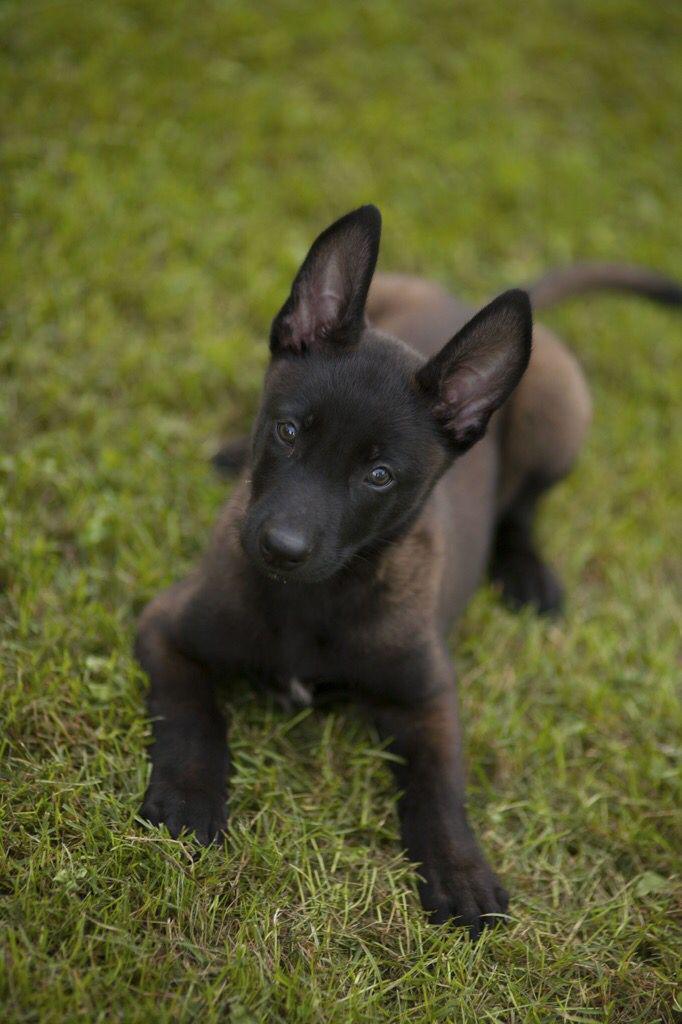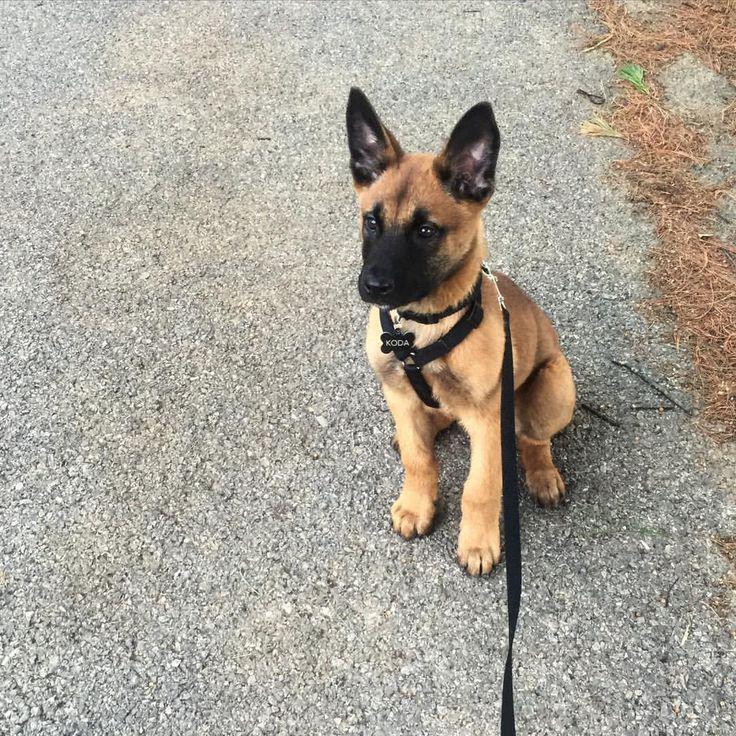The first image is the image on the left, the second image is the image on the right. Assess this claim about the two images: "A little dog in one image, with ears and tail standing up, has one front paw up in a walking stance.". Correct or not? Answer yes or no. No. The first image is the image on the left, the second image is the image on the right. Analyze the images presented: Is the assertion "A brown puppy has a visible leash." valid? Answer yes or no. Yes. 